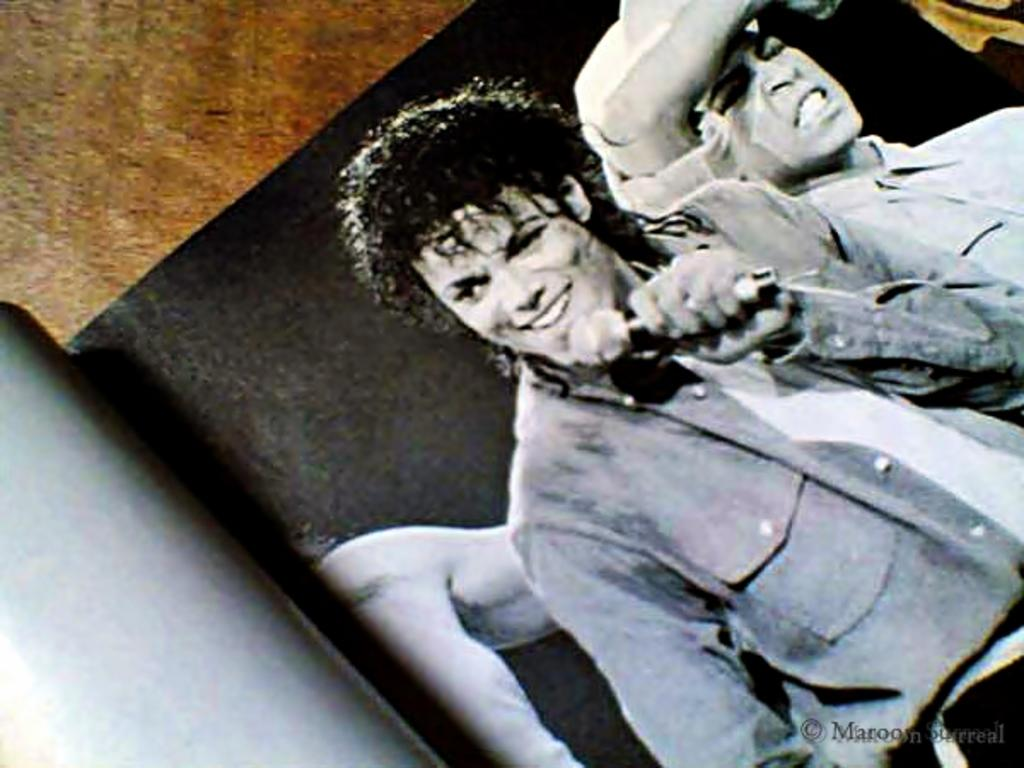What is the main subject in the foreground of the image? There is a book in the foreground of the image. What can be seen inside the book? There are persons depicted in the book. What is the man in the image holding? The man is holding a microphone in the image. What type of wave can be seen crashing on the shore in the image? There is no wave or shore present in the image; it features a book with persons depicted and a man holding a microphone. 